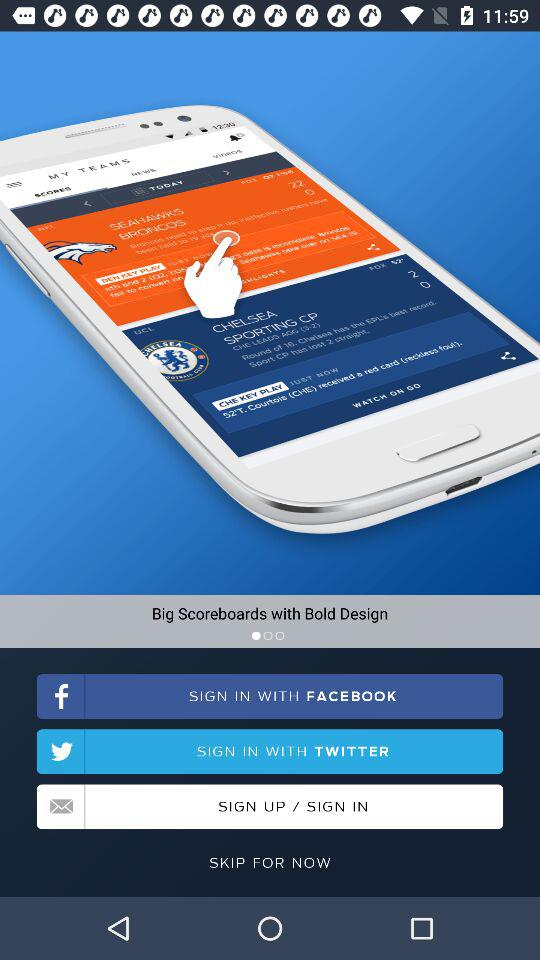What are the different options to sign in? The different options to sign in are "FACEBOOK", "TWITTER" and "Email". 